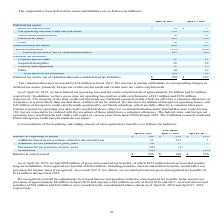According to Netapp's financial document, How much was the amount of gross unrecognized tax benefits in 2019? According to the financial document, $296 million. The relevant text states: "As of April 26, 2019, we had $296 million of gross unrecognized tax benefits, of which $252 million has been recorded in other long-term liabi..." Also, Which years does the table provide information for the reconciliation of the beginning and ending amount of unrecognized tax benefits? The document contains multiple relevant values: 2019, 2018, 2017. From the document: "April 26, 2019 April 27, 2018 April 28, 2017 April 26, 2019 April 27, 2018 April 28, 2017 April 26, 2019 April 27, 2018 April 28, 2017..." Also, What were the Additions based on tax positions related to the current year in 2019? According to the financial document, 11 (in millions). The relevant text states: "ased on tax positions related to the current year 11 131 7..." Also, can you calculate: What was the change in the Balance at beginning of period between 2017 and 2018? Based on the calculation: 218-216, the result is 2 (in millions). This is based on the information: "Balance at beginning of period $ 348 $ 218 $ 216 Balance at beginning of period $ 348 $ 218 $ 216..." The key data points involved are: 216, 218. Also, can you calculate: What was the total change in Additions for tax positions of prior years between 2017 and 2019? Based on the calculation: 26-7, the result is 19 (in millions). This is based on the information: "April 26, 2019 April 27, 2018 April 28, 2017 April 26, 2019 April 27, 2018 April 28, 2017..." The key data points involved are: 26, 7. Also, can you calculate: What was the percentage change in the Balance at end of period between 2018 and 2019? To answer this question, I need to perform calculations using the financial data. The calculation is: (296-348)/348, which equals -14.94 (percentage). This is based on the information: "Balance at end of period $ 296 $ 348 $ 218 Balance at end of period $ 296 $ 348 $ 218..." The key data points involved are: 296, 348. 